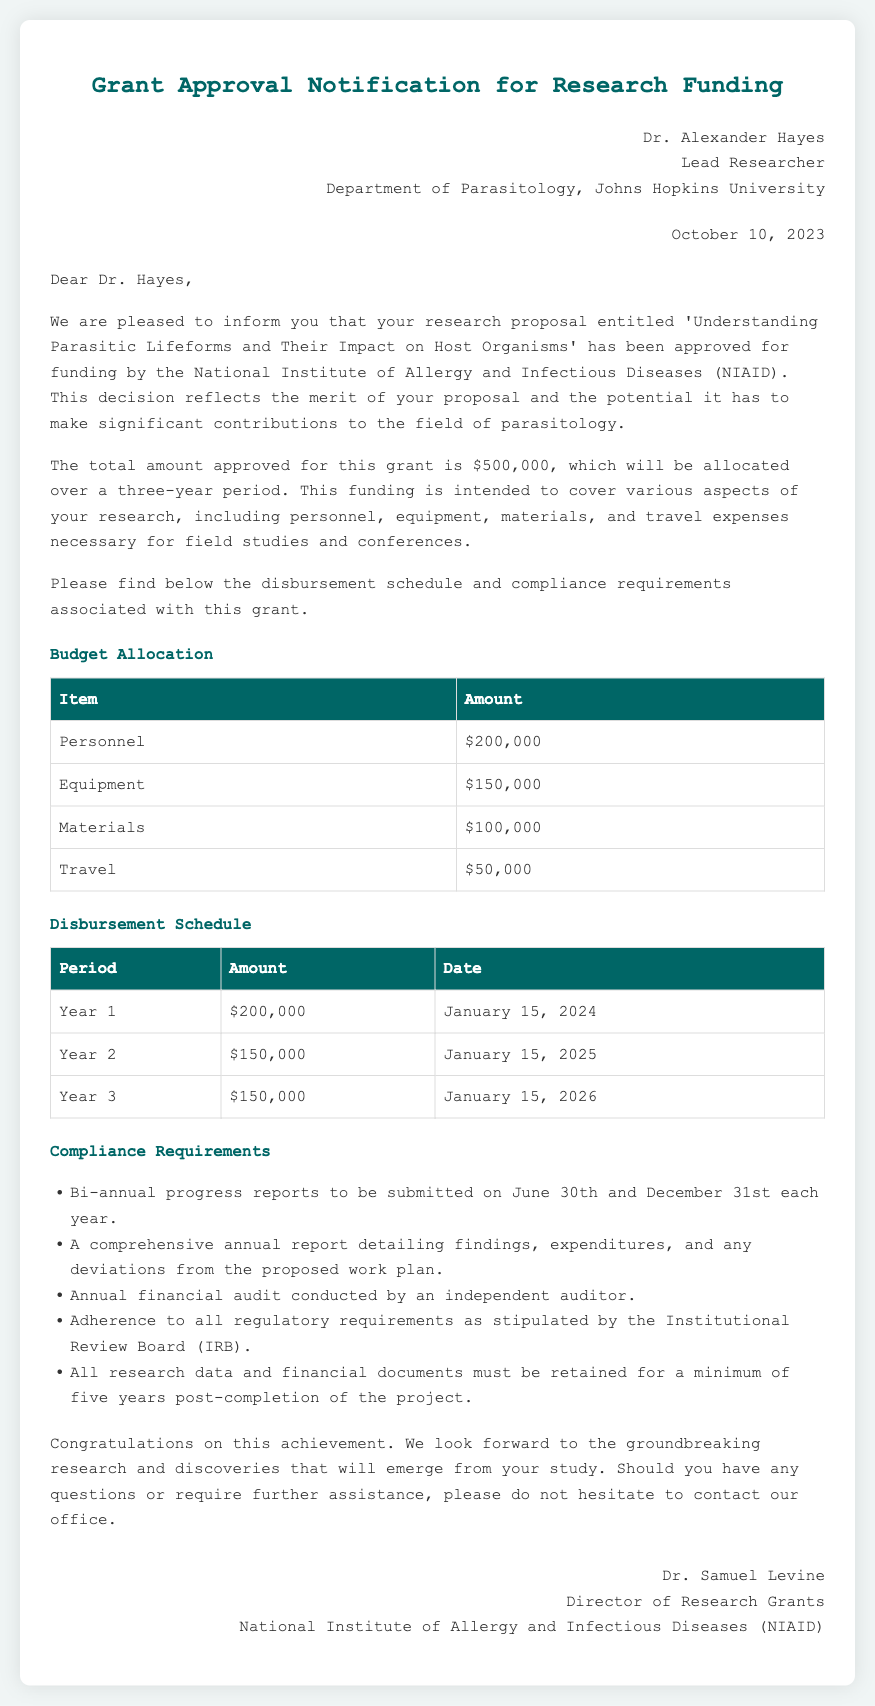What is the total amount approved for the grant? The total amount approved for the grant is stated clearly in the document as $500,000.
Answer: $500,000 Who is the lead researcher? The document specifies Dr. Alexander Hayes as the lead researcher for the project.
Answer: Dr. Alexander Hayes When is the first disbursement scheduled? The disbursement schedule indicates that the first payment will be made on January 15, 2024.
Answer: January 15, 2024 What percentage of the budget is allocated to personnel? To determine this, we look at the personnel budget of $200,000 compared to the total budget of $500,000, which constitutes 40%.
Answer: 40% What is one of the compliance requirements? The document lists multiple compliance requirements; one of them is bi-annual progress reports to be submitted on June 30th and December 31st each year.
Answer: Bi-annual progress reports What is the total amount allocated for travel? The total amount allocated for travel expenses given in the budget is $50,000.
Answer: $50,000 What will be the amount in Year 3 disbursement? The document specifies that the Year 3 disbursement will be $150,000.
Answer: $150,000 Who is the director of research grants? The document mentions Dr. Samuel Levine as the director of research grants at NIAID.
Answer: Dr. Samuel Levine What is the date of this grant approval notification? The notification date is explicitly stated as October 10, 2023.
Answer: October 10, 2023 